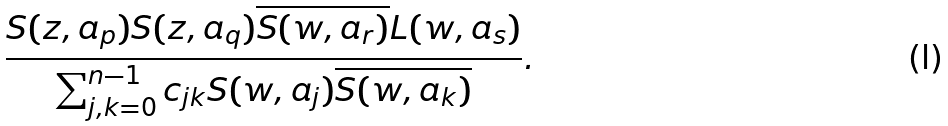Convert formula to latex. <formula><loc_0><loc_0><loc_500><loc_500>\frac { S ( z , a _ { p } ) S ( z , a _ { q } ) \overline { S ( w , a _ { r } ) } L ( w , a _ { s } ) } { \sum _ { j , k = 0 } ^ { n - 1 } c _ { j k } S ( w , a _ { j } ) \overline { S ( w , a _ { k } ) } } .</formula> 